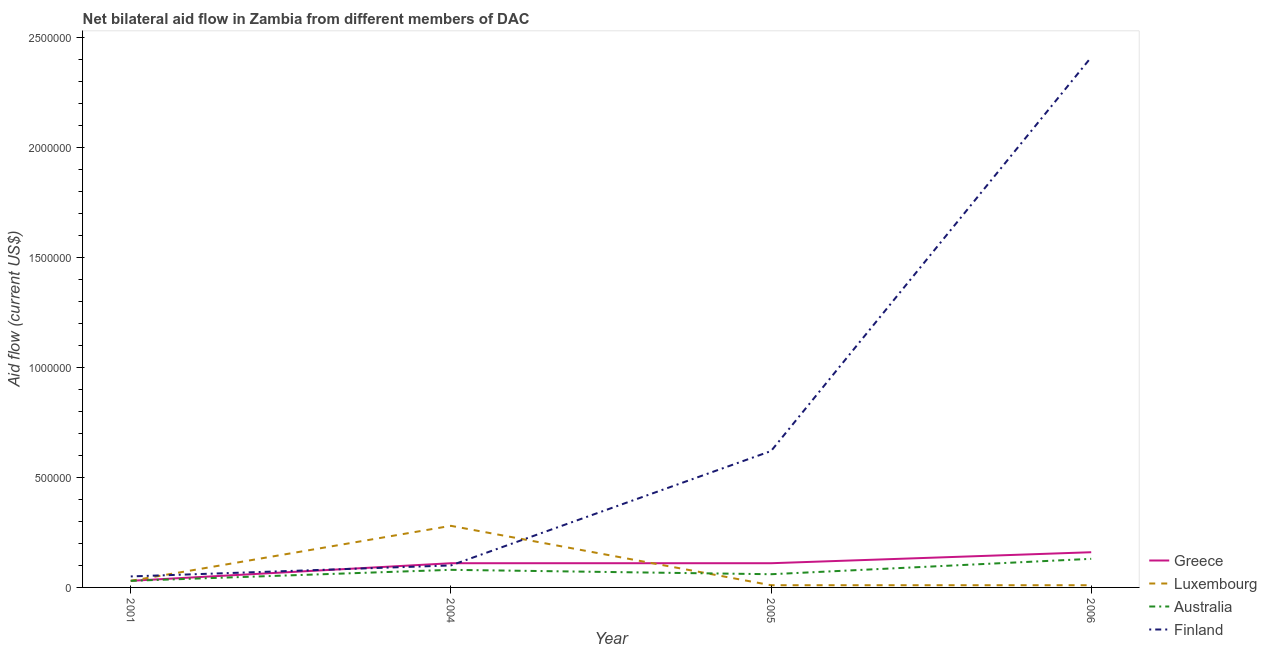How many different coloured lines are there?
Offer a terse response. 4. Is the number of lines equal to the number of legend labels?
Keep it short and to the point. Yes. What is the amount of aid given by finland in 2004?
Your answer should be very brief. 1.00e+05. Across all years, what is the maximum amount of aid given by greece?
Ensure brevity in your answer.  1.60e+05. Across all years, what is the minimum amount of aid given by finland?
Provide a short and direct response. 5.00e+04. What is the total amount of aid given by greece in the graph?
Ensure brevity in your answer.  4.10e+05. What is the difference between the amount of aid given by luxembourg in 2004 and that in 2006?
Ensure brevity in your answer.  2.70e+05. What is the difference between the amount of aid given by australia in 2004 and the amount of aid given by finland in 2006?
Offer a terse response. -2.33e+06. What is the average amount of aid given by greece per year?
Provide a succinct answer. 1.02e+05. In the year 2004, what is the difference between the amount of aid given by greece and amount of aid given by luxembourg?
Provide a succinct answer. -1.70e+05. What is the ratio of the amount of aid given by luxembourg in 2005 to that in 2006?
Your answer should be compact. 1. Is the difference between the amount of aid given by finland in 2004 and 2005 greater than the difference between the amount of aid given by australia in 2004 and 2005?
Provide a short and direct response. No. What is the difference between the highest and the second highest amount of aid given by finland?
Give a very brief answer. 1.79e+06. What is the difference between the highest and the lowest amount of aid given by luxembourg?
Provide a short and direct response. 2.70e+05. In how many years, is the amount of aid given by luxembourg greater than the average amount of aid given by luxembourg taken over all years?
Keep it short and to the point. 1. Is the sum of the amount of aid given by greece in 2005 and 2006 greater than the maximum amount of aid given by luxembourg across all years?
Make the answer very short. No. Is it the case that in every year, the sum of the amount of aid given by finland and amount of aid given by australia is greater than the sum of amount of aid given by luxembourg and amount of aid given by greece?
Your answer should be very brief. No. Does the amount of aid given by greece monotonically increase over the years?
Provide a short and direct response. No. Is the amount of aid given by luxembourg strictly greater than the amount of aid given by australia over the years?
Your answer should be very brief. No. How many lines are there?
Your answer should be compact. 4. What is the difference between two consecutive major ticks on the Y-axis?
Provide a succinct answer. 5.00e+05. Are the values on the major ticks of Y-axis written in scientific E-notation?
Ensure brevity in your answer.  No. Does the graph contain any zero values?
Provide a short and direct response. No. Does the graph contain grids?
Your answer should be compact. No. Where does the legend appear in the graph?
Give a very brief answer. Bottom right. How many legend labels are there?
Provide a short and direct response. 4. How are the legend labels stacked?
Offer a very short reply. Vertical. What is the title of the graph?
Ensure brevity in your answer.  Net bilateral aid flow in Zambia from different members of DAC. What is the label or title of the Y-axis?
Offer a very short reply. Aid flow (current US$). What is the Aid flow (current US$) of Greece in 2001?
Your answer should be compact. 3.00e+04. What is the Aid flow (current US$) in Luxembourg in 2001?
Make the answer very short. 3.00e+04. What is the Aid flow (current US$) of Greece in 2004?
Offer a terse response. 1.10e+05. What is the Aid flow (current US$) of Luxembourg in 2004?
Give a very brief answer. 2.80e+05. What is the Aid flow (current US$) in Australia in 2004?
Your response must be concise. 8.00e+04. What is the Aid flow (current US$) of Finland in 2004?
Ensure brevity in your answer.  1.00e+05. What is the Aid flow (current US$) in Australia in 2005?
Your answer should be compact. 6.00e+04. What is the Aid flow (current US$) in Finland in 2005?
Your answer should be very brief. 6.20e+05. What is the Aid flow (current US$) in Greece in 2006?
Keep it short and to the point. 1.60e+05. What is the Aid flow (current US$) in Finland in 2006?
Your response must be concise. 2.41e+06. Across all years, what is the maximum Aid flow (current US$) of Luxembourg?
Give a very brief answer. 2.80e+05. Across all years, what is the maximum Aid flow (current US$) of Australia?
Give a very brief answer. 1.30e+05. Across all years, what is the maximum Aid flow (current US$) of Finland?
Provide a succinct answer. 2.41e+06. Across all years, what is the minimum Aid flow (current US$) in Greece?
Your response must be concise. 3.00e+04. What is the total Aid flow (current US$) in Greece in the graph?
Your answer should be compact. 4.10e+05. What is the total Aid flow (current US$) in Luxembourg in the graph?
Keep it short and to the point. 3.30e+05. What is the total Aid flow (current US$) in Australia in the graph?
Offer a very short reply. 3.00e+05. What is the total Aid flow (current US$) in Finland in the graph?
Your response must be concise. 3.18e+06. What is the difference between the Aid flow (current US$) in Luxembourg in 2001 and that in 2004?
Make the answer very short. -2.50e+05. What is the difference between the Aid flow (current US$) of Australia in 2001 and that in 2004?
Your answer should be compact. -5.00e+04. What is the difference between the Aid flow (current US$) in Australia in 2001 and that in 2005?
Your answer should be compact. -3.00e+04. What is the difference between the Aid flow (current US$) in Finland in 2001 and that in 2005?
Your answer should be very brief. -5.70e+05. What is the difference between the Aid flow (current US$) in Greece in 2001 and that in 2006?
Provide a short and direct response. -1.30e+05. What is the difference between the Aid flow (current US$) in Finland in 2001 and that in 2006?
Provide a succinct answer. -2.36e+06. What is the difference between the Aid flow (current US$) in Luxembourg in 2004 and that in 2005?
Offer a terse response. 2.70e+05. What is the difference between the Aid flow (current US$) of Australia in 2004 and that in 2005?
Keep it short and to the point. 2.00e+04. What is the difference between the Aid flow (current US$) of Finland in 2004 and that in 2005?
Your answer should be very brief. -5.20e+05. What is the difference between the Aid flow (current US$) of Finland in 2004 and that in 2006?
Offer a very short reply. -2.31e+06. What is the difference between the Aid flow (current US$) of Finland in 2005 and that in 2006?
Your answer should be very brief. -1.79e+06. What is the difference between the Aid flow (current US$) of Greece in 2001 and the Aid flow (current US$) of Luxembourg in 2004?
Give a very brief answer. -2.50e+05. What is the difference between the Aid flow (current US$) of Greece in 2001 and the Aid flow (current US$) of Australia in 2004?
Your answer should be very brief. -5.00e+04. What is the difference between the Aid flow (current US$) of Greece in 2001 and the Aid flow (current US$) of Finland in 2004?
Provide a short and direct response. -7.00e+04. What is the difference between the Aid flow (current US$) of Luxembourg in 2001 and the Aid flow (current US$) of Australia in 2004?
Ensure brevity in your answer.  -5.00e+04. What is the difference between the Aid flow (current US$) in Greece in 2001 and the Aid flow (current US$) in Luxembourg in 2005?
Provide a short and direct response. 2.00e+04. What is the difference between the Aid flow (current US$) of Greece in 2001 and the Aid flow (current US$) of Australia in 2005?
Ensure brevity in your answer.  -3.00e+04. What is the difference between the Aid flow (current US$) in Greece in 2001 and the Aid flow (current US$) in Finland in 2005?
Ensure brevity in your answer.  -5.90e+05. What is the difference between the Aid flow (current US$) in Luxembourg in 2001 and the Aid flow (current US$) in Finland in 2005?
Offer a very short reply. -5.90e+05. What is the difference between the Aid flow (current US$) of Australia in 2001 and the Aid flow (current US$) of Finland in 2005?
Your answer should be very brief. -5.90e+05. What is the difference between the Aid flow (current US$) of Greece in 2001 and the Aid flow (current US$) of Luxembourg in 2006?
Offer a very short reply. 2.00e+04. What is the difference between the Aid flow (current US$) in Greece in 2001 and the Aid flow (current US$) in Finland in 2006?
Make the answer very short. -2.38e+06. What is the difference between the Aid flow (current US$) in Luxembourg in 2001 and the Aid flow (current US$) in Australia in 2006?
Offer a very short reply. -1.00e+05. What is the difference between the Aid flow (current US$) of Luxembourg in 2001 and the Aid flow (current US$) of Finland in 2006?
Offer a terse response. -2.38e+06. What is the difference between the Aid flow (current US$) in Australia in 2001 and the Aid flow (current US$) in Finland in 2006?
Provide a short and direct response. -2.38e+06. What is the difference between the Aid flow (current US$) in Greece in 2004 and the Aid flow (current US$) in Luxembourg in 2005?
Your answer should be compact. 1.00e+05. What is the difference between the Aid flow (current US$) of Greece in 2004 and the Aid flow (current US$) of Australia in 2005?
Ensure brevity in your answer.  5.00e+04. What is the difference between the Aid flow (current US$) in Greece in 2004 and the Aid flow (current US$) in Finland in 2005?
Your response must be concise. -5.10e+05. What is the difference between the Aid flow (current US$) in Luxembourg in 2004 and the Aid flow (current US$) in Finland in 2005?
Give a very brief answer. -3.40e+05. What is the difference between the Aid flow (current US$) in Australia in 2004 and the Aid flow (current US$) in Finland in 2005?
Offer a very short reply. -5.40e+05. What is the difference between the Aid flow (current US$) in Greece in 2004 and the Aid flow (current US$) in Australia in 2006?
Ensure brevity in your answer.  -2.00e+04. What is the difference between the Aid flow (current US$) in Greece in 2004 and the Aid flow (current US$) in Finland in 2006?
Your answer should be compact. -2.30e+06. What is the difference between the Aid flow (current US$) in Luxembourg in 2004 and the Aid flow (current US$) in Australia in 2006?
Make the answer very short. 1.50e+05. What is the difference between the Aid flow (current US$) of Luxembourg in 2004 and the Aid flow (current US$) of Finland in 2006?
Your answer should be compact. -2.13e+06. What is the difference between the Aid flow (current US$) in Australia in 2004 and the Aid flow (current US$) in Finland in 2006?
Ensure brevity in your answer.  -2.33e+06. What is the difference between the Aid flow (current US$) in Greece in 2005 and the Aid flow (current US$) in Finland in 2006?
Ensure brevity in your answer.  -2.30e+06. What is the difference between the Aid flow (current US$) of Luxembourg in 2005 and the Aid flow (current US$) of Finland in 2006?
Your response must be concise. -2.40e+06. What is the difference between the Aid flow (current US$) of Australia in 2005 and the Aid flow (current US$) of Finland in 2006?
Make the answer very short. -2.35e+06. What is the average Aid flow (current US$) of Greece per year?
Offer a terse response. 1.02e+05. What is the average Aid flow (current US$) in Luxembourg per year?
Make the answer very short. 8.25e+04. What is the average Aid flow (current US$) in Australia per year?
Make the answer very short. 7.50e+04. What is the average Aid flow (current US$) in Finland per year?
Ensure brevity in your answer.  7.95e+05. In the year 2001, what is the difference between the Aid flow (current US$) of Luxembourg and Aid flow (current US$) of Finland?
Make the answer very short. -2.00e+04. In the year 2001, what is the difference between the Aid flow (current US$) in Australia and Aid flow (current US$) in Finland?
Your response must be concise. -2.00e+04. In the year 2004, what is the difference between the Aid flow (current US$) of Greece and Aid flow (current US$) of Australia?
Your answer should be very brief. 3.00e+04. In the year 2004, what is the difference between the Aid flow (current US$) of Greece and Aid flow (current US$) of Finland?
Give a very brief answer. 10000. In the year 2004, what is the difference between the Aid flow (current US$) in Luxembourg and Aid flow (current US$) in Australia?
Provide a succinct answer. 2.00e+05. In the year 2004, what is the difference between the Aid flow (current US$) of Luxembourg and Aid flow (current US$) of Finland?
Offer a very short reply. 1.80e+05. In the year 2004, what is the difference between the Aid flow (current US$) in Australia and Aid flow (current US$) in Finland?
Your answer should be compact. -2.00e+04. In the year 2005, what is the difference between the Aid flow (current US$) in Greece and Aid flow (current US$) in Australia?
Offer a very short reply. 5.00e+04. In the year 2005, what is the difference between the Aid flow (current US$) of Greece and Aid flow (current US$) of Finland?
Your answer should be very brief. -5.10e+05. In the year 2005, what is the difference between the Aid flow (current US$) in Luxembourg and Aid flow (current US$) in Australia?
Make the answer very short. -5.00e+04. In the year 2005, what is the difference between the Aid flow (current US$) in Luxembourg and Aid flow (current US$) in Finland?
Keep it short and to the point. -6.10e+05. In the year 2005, what is the difference between the Aid flow (current US$) in Australia and Aid flow (current US$) in Finland?
Make the answer very short. -5.60e+05. In the year 2006, what is the difference between the Aid flow (current US$) in Greece and Aid flow (current US$) in Finland?
Keep it short and to the point. -2.25e+06. In the year 2006, what is the difference between the Aid flow (current US$) of Luxembourg and Aid flow (current US$) of Finland?
Provide a short and direct response. -2.40e+06. In the year 2006, what is the difference between the Aid flow (current US$) in Australia and Aid flow (current US$) in Finland?
Your response must be concise. -2.28e+06. What is the ratio of the Aid flow (current US$) in Greece in 2001 to that in 2004?
Your answer should be very brief. 0.27. What is the ratio of the Aid flow (current US$) of Luxembourg in 2001 to that in 2004?
Keep it short and to the point. 0.11. What is the ratio of the Aid flow (current US$) of Finland in 2001 to that in 2004?
Your answer should be compact. 0.5. What is the ratio of the Aid flow (current US$) of Greece in 2001 to that in 2005?
Keep it short and to the point. 0.27. What is the ratio of the Aid flow (current US$) of Australia in 2001 to that in 2005?
Give a very brief answer. 0.5. What is the ratio of the Aid flow (current US$) of Finland in 2001 to that in 2005?
Your answer should be compact. 0.08. What is the ratio of the Aid flow (current US$) in Greece in 2001 to that in 2006?
Keep it short and to the point. 0.19. What is the ratio of the Aid flow (current US$) in Australia in 2001 to that in 2006?
Ensure brevity in your answer.  0.23. What is the ratio of the Aid flow (current US$) of Finland in 2001 to that in 2006?
Ensure brevity in your answer.  0.02. What is the ratio of the Aid flow (current US$) in Finland in 2004 to that in 2005?
Keep it short and to the point. 0.16. What is the ratio of the Aid flow (current US$) of Greece in 2004 to that in 2006?
Your answer should be compact. 0.69. What is the ratio of the Aid flow (current US$) in Australia in 2004 to that in 2006?
Ensure brevity in your answer.  0.62. What is the ratio of the Aid flow (current US$) in Finland in 2004 to that in 2006?
Make the answer very short. 0.04. What is the ratio of the Aid flow (current US$) of Greece in 2005 to that in 2006?
Provide a short and direct response. 0.69. What is the ratio of the Aid flow (current US$) of Luxembourg in 2005 to that in 2006?
Your response must be concise. 1. What is the ratio of the Aid flow (current US$) of Australia in 2005 to that in 2006?
Your answer should be compact. 0.46. What is the ratio of the Aid flow (current US$) in Finland in 2005 to that in 2006?
Offer a terse response. 0.26. What is the difference between the highest and the second highest Aid flow (current US$) in Greece?
Ensure brevity in your answer.  5.00e+04. What is the difference between the highest and the second highest Aid flow (current US$) in Luxembourg?
Your response must be concise. 2.50e+05. What is the difference between the highest and the second highest Aid flow (current US$) in Finland?
Provide a short and direct response. 1.79e+06. What is the difference between the highest and the lowest Aid flow (current US$) in Greece?
Your answer should be very brief. 1.30e+05. What is the difference between the highest and the lowest Aid flow (current US$) of Finland?
Offer a terse response. 2.36e+06. 